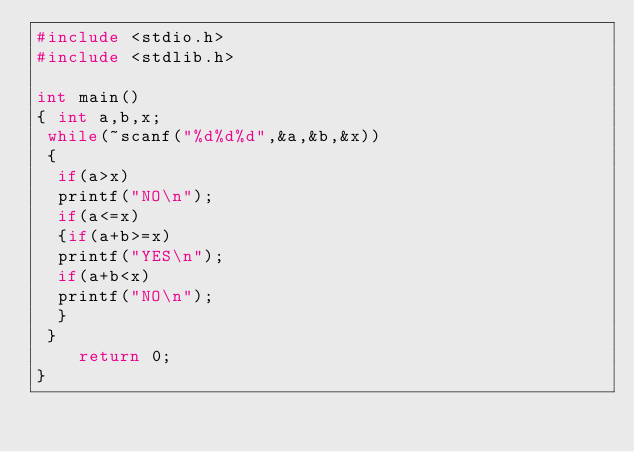<code> <loc_0><loc_0><loc_500><loc_500><_C_>#include <stdio.h>
#include <stdlib.h>

int main()
{ int a,b,x;
 while(~scanf("%d%d%d",&a,&b,&x))
 {
  if(a>x)
  printf("NO\n");
  if(a<=x)
  {if(a+b>=x)
  printf("YES\n");
  if(a+b<x)
  printf("NO\n");
  }
 }
    return 0;
}
</code> 